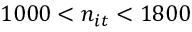Convert formula to latex. <formula><loc_0><loc_0><loc_500><loc_500>1 0 0 0 < n _ { i t } < 1 8 0 0</formula> 